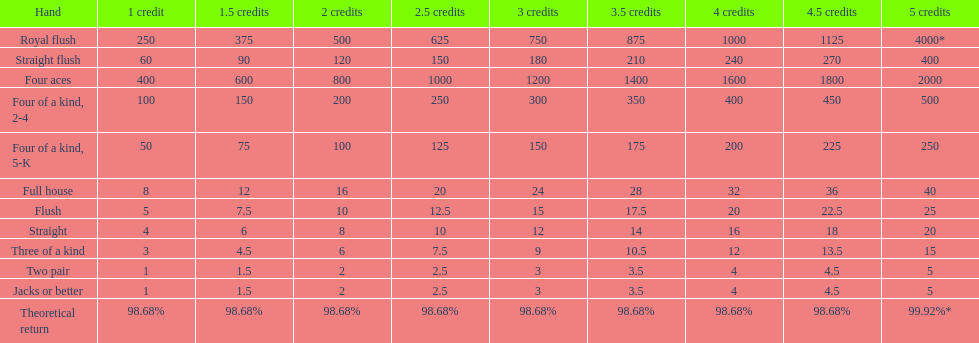Each four aces win is a multiple of what number? 400. 